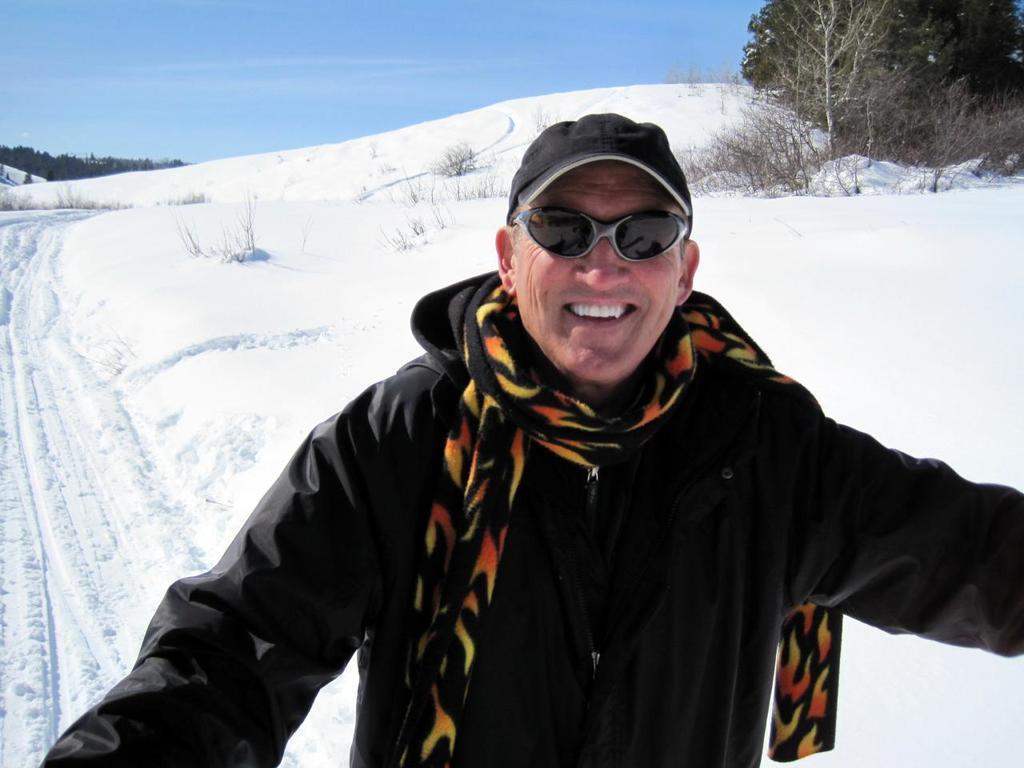Could you give a brief overview of what you see in this image? In the picture I can see a person wearing black color jacket, scarf, cap and glasses is standing here and smiling. In the background, we can see trees on the right side of the image and the sky in the background. 